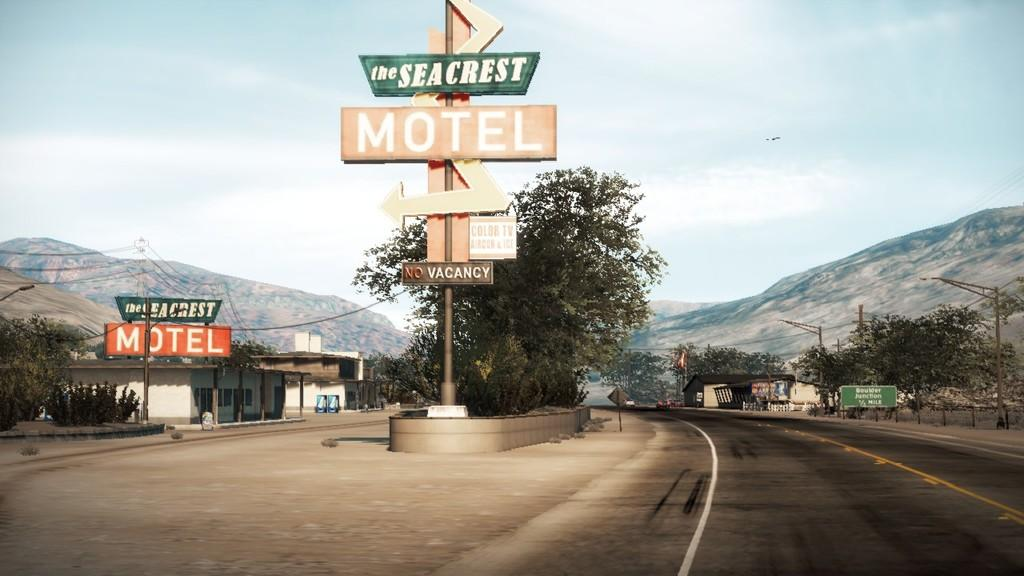<image>
Offer a succinct explanation of the picture presented. Two signs for the Seacrest Motel, one has a vacancy/no vacancy neon sign on it. 